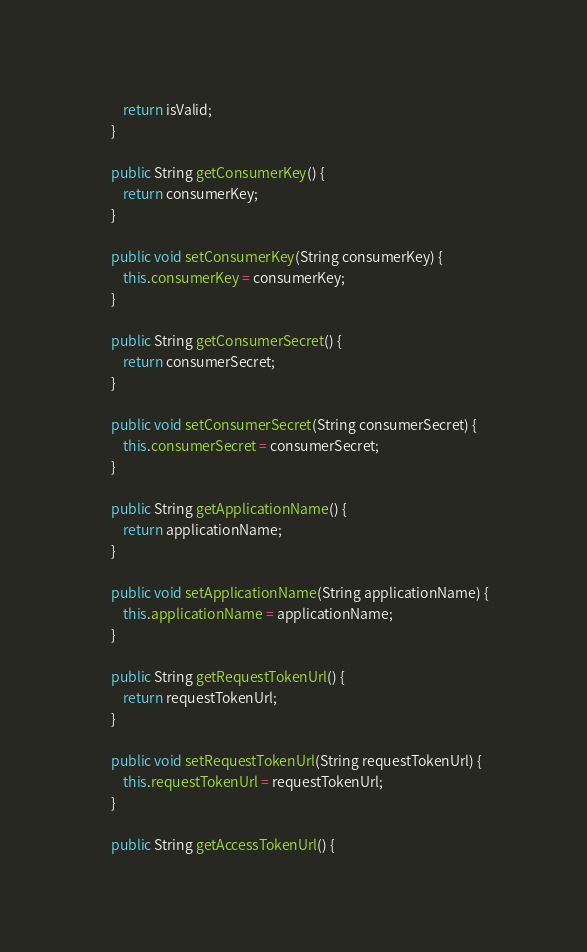Convert code to text. <code><loc_0><loc_0><loc_500><loc_500><_Java_>		return isValid;
	}

	public String getConsumerKey() {
		return consumerKey;
	}

	public void setConsumerKey(String consumerKey) {
		this.consumerKey = consumerKey;
	}

	public String getConsumerSecret() {
		return consumerSecret;
	}

	public void setConsumerSecret(String consumerSecret) {
		this.consumerSecret = consumerSecret;
	}

	public String getApplicationName() {
		return applicationName;
	}

	public void setApplicationName(String applicationName) {
		this.applicationName = applicationName;
	}

	public String getRequestTokenUrl() {
		return requestTokenUrl;
	}

	public void setRequestTokenUrl(String requestTokenUrl) {
		this.requestTokenUrl = requestTokenUrl;
	}

	public String getAccessTokenUrl() {</code> 